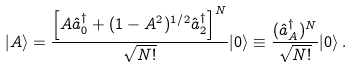Convert formula to latex. <formula><loc_0><loc_0><loc_500><loc_500>| A \rangle = \frac { \left [ A \hat { a } _ { 0 } ^ { \dagger } + ( 1 - A ^ { 2 } ) ^ { 1 / 2 } \hat { a } _ { 2 } ^ { \dagger } \right ] ^ { N } } { \sqrt { N ! } } | 0 \rangle \equiv \frac { ( \hat { a } ^ { \dagger } _ { A } ) ^ { N } } { \sqrt { N ! } } | 0 \rangle \, .</formula> 